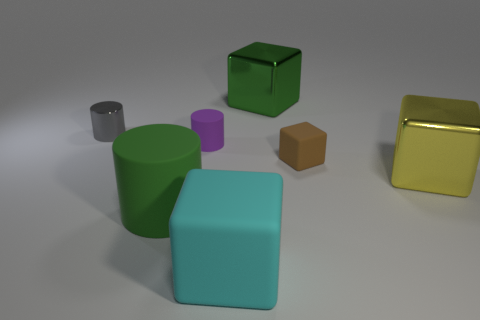Subtract all red cubes. Subtract all purple balls. How many cubes are left? 4 Add 2 gray objects. How many objects exist? 9 Subtract all cylinders. How many objects are left? 4 Add 7 large cylinders. How many large cylinders are left? 8 Add 4 big yellow things. How many big yellow things exist? 5 Subtract 1 green cubes. How many objects are left? 6 Subtract all green metallic things. Subtract all tiny blue balls. How many objects are left? 6 